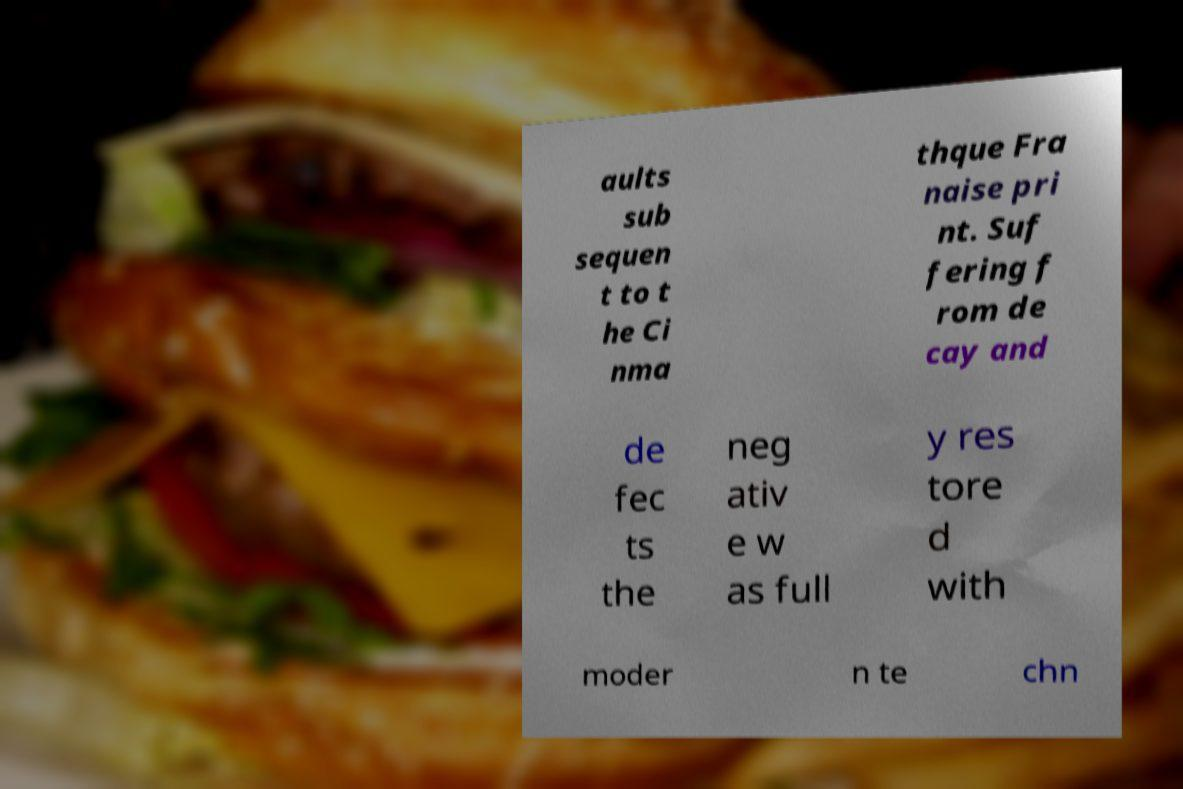Can you read and provide the text displayed in the image?This photo seems to have some interesting text. Can you extract and type it out for me? aults sub sequen t to t he Ci nma thque Fra naise pri nt. Suf fering f rom de cay and de fec ts the neg ativ e w as full y res tore d with moder n te chn 